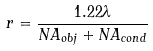<formula> <loc_0><loc_0><loc_500><loc_500>r = { \frac { 1 . 2 2 \lambda } { N A _ { o b j } + N A _ { c o n d } } }</formula> 